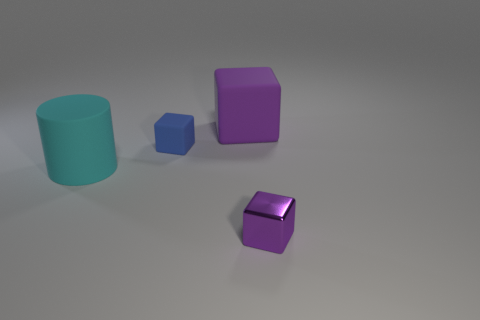Subtract all large matte cubes. How many cubes are left? 2 Subtract all purple cubes. How many cubes are left? 1 Add 3 rubber cylinders. How many objects exist? 7 Subtract 1 cylinders. How many cylinders are left? 0 Subtract all cylinders. How many objects are left? 3 Subtract all yellow blocks. Subtract all blue cylinders. How many blocks are left? 3 Subtract all blue cylinders. How many purple blocks are left? 2 Subtract all big gray objects. Subtract all cubes. How many objects are left? 1 Add 4 big purple rubber cubes. How many big purple rubber cubes are left? 5 Add 3 matte blocks. How many matte blocks exist? 5 